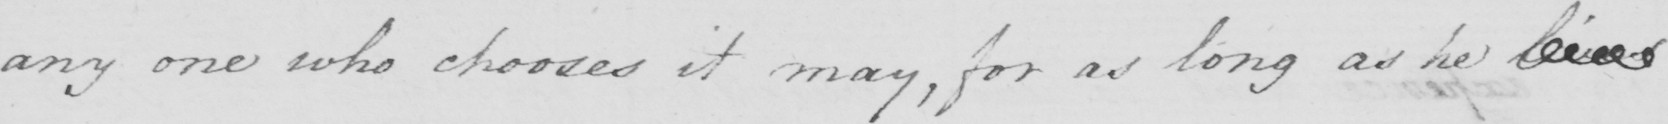Can you tell me what this handwritten text says? any one who chooses it may , for as long as he lives 